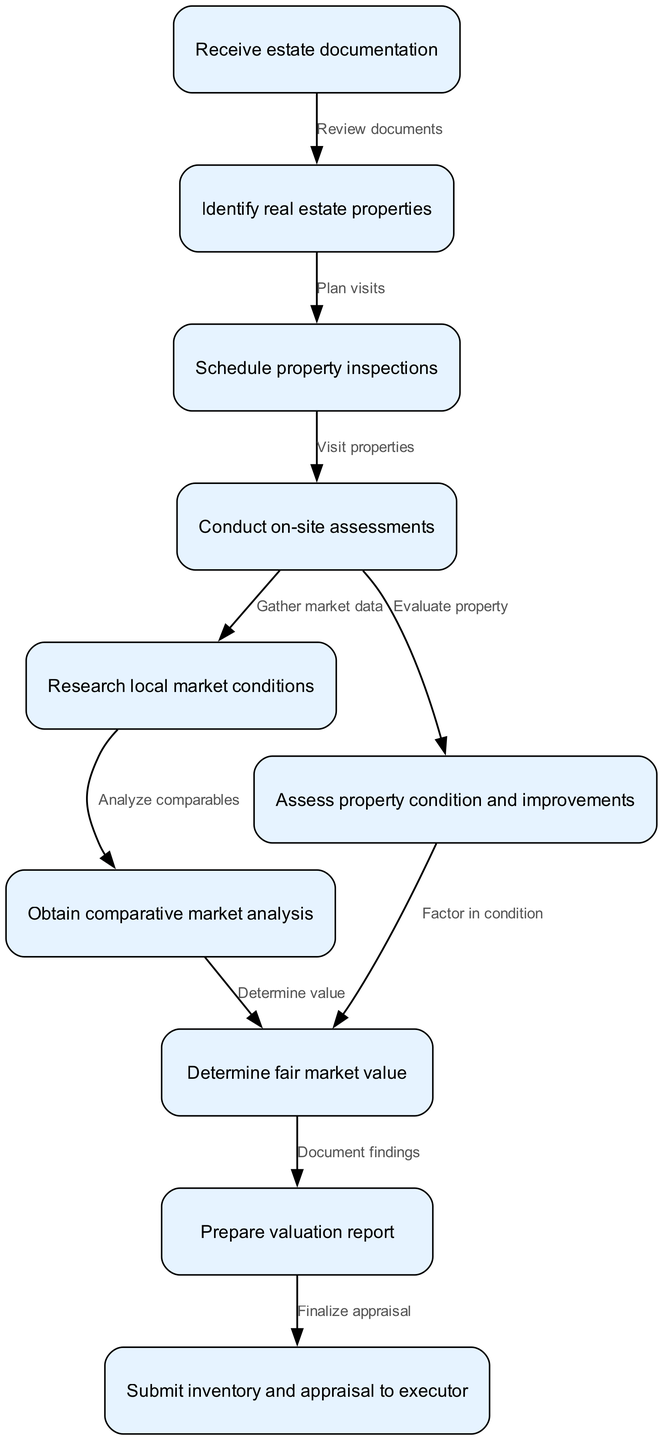What is the total number of nodes in the diagram? The diagram lists nodes for each main step in the inventory and valuation workflow. By counting the nodes in the data provided, we can determine that there are ten nodes present.
Answer: 10 What is the first step in the workflow? The first node in the workflow, according to the diagram, is labeled as "Receive estate documentation." This indicates the initial action taken at the beginning of the process.
Answer: Receive estate documentation How many edges are present in the diagram? Each edge represents a connection or relationship between two nodes. By examining the edges listed, we find that there are nine edges connecting the nodes in the workflow.
Answer: 9 What happens after conducting on-site assessments? Following the node "Conduct on-site assessments," the next step in the workflow is to "Research local market conditions." This indicates the sequential progression of steps following the assessment.
Answer: Research local market conditions What does the node "Determine fair market value" follow? In the workflow, the node "Determine fair market value" is dependent on the completion of both "Obtain comparative market analysis" and "Assess property condition and improvements." These actions must occur prior to determining the property's fair market value.
Answer: Obtain comparative market analysis and Assess property condition and improvements Which step immediately precedes "Prepare valuation report"? The node that comes right before "Prepare valuation report" is "Determine fair market value." This indicates that the valuation report preparation is contingent upon completing the valuation determination.
Answer: Determine fair market value How are market conditions researched? The research of local market conditions is initiated after on-site assessments. It follows the gathering of information gained from the assessments and precedes the analysis of comparative market data.
Answer: Gather market data Which nodes require information from the "Conduct on-site assessments"? Two nodes depend on information gathered during "Conduct on-site assessments": "Research local market conditions" and "Assess property condition and improvements." Both nodes rely on the outcomes of on-site evaluations.
Answer: Research local market conditions and Assess property condition and improvements What is the final step in this workflow? According to the structure of the diagram, the final step in the estate inventory and valuation workflow is "Submit inventory and appraisal to executor." This marks the completion of the workflow process.
Answer: Submit inventory and appraisal to executor 